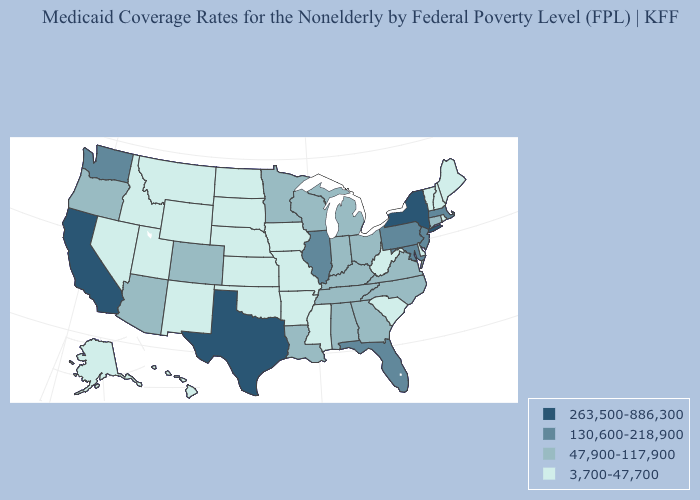Does California have the highest value in the West?
Give a very brief answer. Yes. Name the states that have a value in the range 3,700-47,700?
Keep it brief. Alaska, Arkansas, Delaware, Hawaii, Idaho, Iowa, Kansas, Maine, Mississippi, Missouri, Montana, Nebraska, Nevada, New Hampshire, New Mexico, North Dakota, Oklahoma, Rhode Island, South Carolina, South Dakota, Utah, Vermont, West Virginia, Wyoming. What is the lowest value in states that border Delaware?
Answer briefly. 130,600-218,900. What is the value of New Jersey?
Quick response, please. 130,600-218,900. Name the states that have a value in the range 263,500-886,300?
Write a very short answer. California, New York, Texas. What is the value of Louisiana?
Concise answer only. 47,900-117,900. Which states have the highest value in the USA?
Be succinct. California, New York, Texas. What is the value of New Mexico?
Short answer required. 3,700-47,700. Among the states that border Pennsylvania , which have the lowest value?
Write a very short answer. Delaware, West Virginia. Name the states that have a value in the range 263,500-886,300?
Be succinct. California, New York, Texas. What is the value of Iowa?
Keep it brief. 3,700-47,700. Among the states that border Kansas , does Oklahoma have the highest value?
Be succinct. No. Does the first symbol in the legend represent the smallest category?
Quick response, please. No. What is the highest value in the South ?
Answer briefly. 263,500-886,300. 